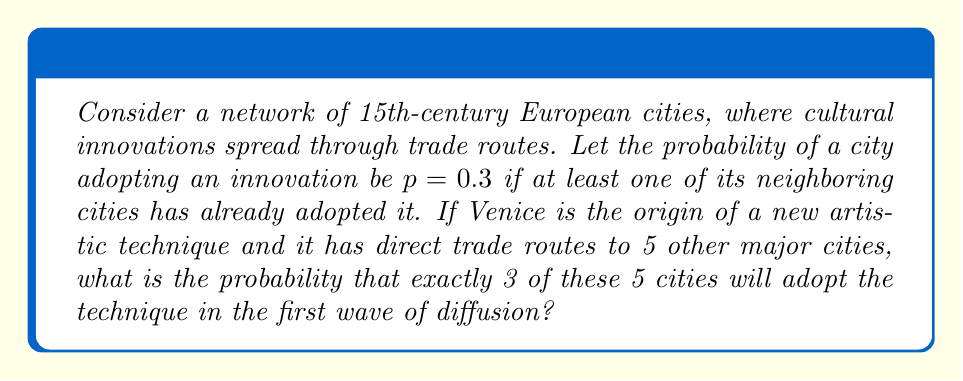Provide a solution to this math problem. To solve this problem, we need to use the concept of binomial probability distribution, which is often applied in game theory and network diffusion models.

1. We have 5 cities, each with an independent probability of $p = 0.3$ of adopting the innovation.

2. We want to find the probability of exactly 3 cities adopting the innovation.

3. This scenario follows a binomial distribution with parameters:
   $n = 5$ (number of trials/cities)
   $k = 3$ (number of successes/adoptions)
   $p = 0.3$ (probability of success/adoption)

4. The binomial probability formula is:

   $$P(X = k) = \binom{n}{k} p^k (1-p)^{n-k}$$

5. Let's calculate each component:

   $\binom{n}{k} = \binom{5}{3} = \frac{5!}{3!(5-3)!} = 10$

   $p^k = 0.3^3 = 0.027$

   $(1-p)^{n-k} = (1-0.3)^{5-3} = 0.7^2 = 0.49$

6. Now, let's plug these values into the formula:

   $$P(X = 3) = 10 \cdot 0.027 \cdot 0.49 = 0.1323$$

Therefore, the probability that exactly 3 out of the 5 cities will adopt the new artistic technique in the first wave of diffusion is approximately 0.1323 or 13.23%.
Answer: 0.1323 (or 13.23%) 